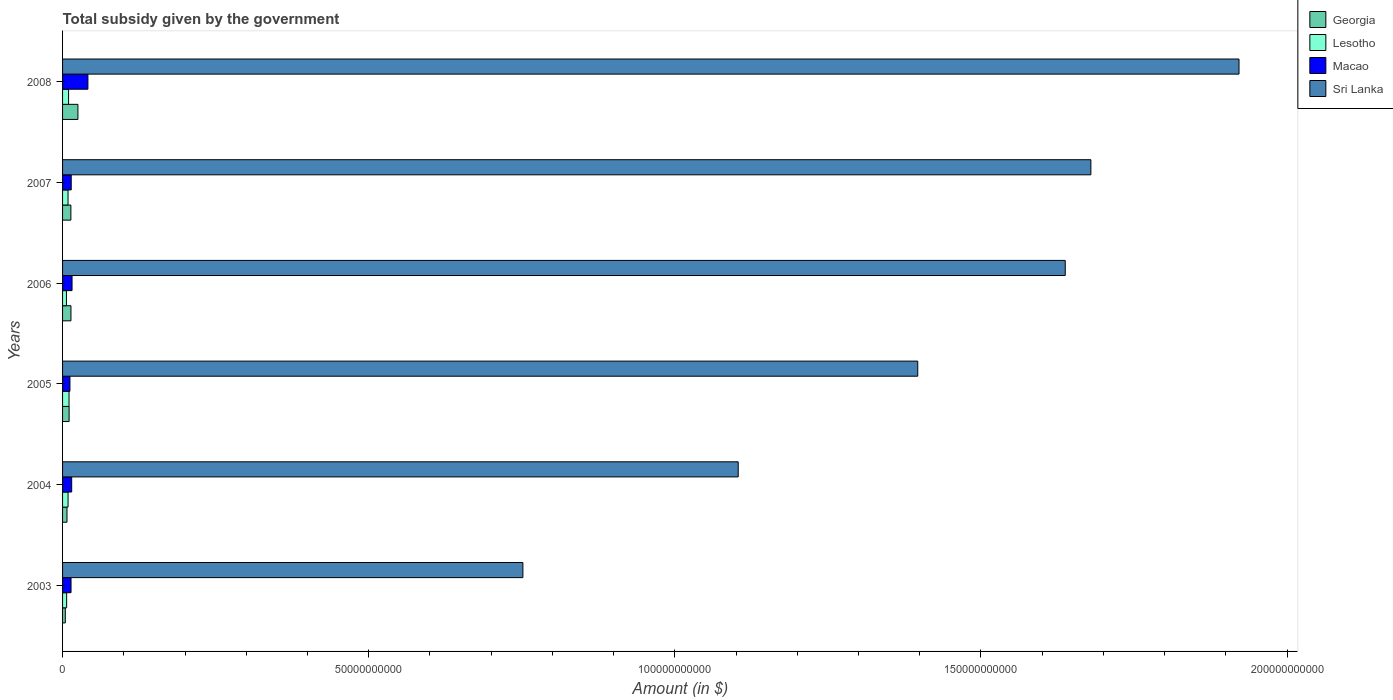How many different coloured bars are there?
Offer a very short reply. 4. Are the number of bars per tick equal to the number of legend labels?
Offer a very short reply. Yes. What is the label of the 3rd group of bars from the top?
Give a very brief answer. 2006. What is the total revenue collected by the government in Macao in 2004?
Your answer should be compact. 1.49e+09. Across all years, what is the maximum total revenue collected by the government in Georgia?
Keep it short and to the point. 2.51e+09. Across all years, what is the minimum total revenue collected by the government in Georgia?
Provide a short and direct response. 4.46e+08. What is the total total revenue collected by the government in Macao in the graph?
Offer a very short reply. 1.12e+1. What is the difference between the total revenue collected by the government in Macao in 2006 and that in 2008?
Offer a terse response. -2.59e+09. What is the difference between the total revenue collected by the government in Sri Lanka in 2006 and the total revenue collected by the government in Macao in 2008?
Give a very brief answer. 1.60e+11. What is the average total revenue collected by the government in Lesotho per year?
Make the answer very short. 8.54e+08. In the year 2006, what is the difference between the total revenue collected by the government in Macao and total revenue collected by the government in Georgia?
Keep it short and to the point. 1.79e+08. What is the ratio of the total revenue collected by the government in Macao in 2004 to that in 2007?
Your answer should be compact. 1.05. What is the difference between the highest and the second highest total revenue collected by the government in Sri Lanka?
Give a very brief answer. 2.42e+1. What is the difference between the highest and the lowest total revenue collected by the government in Georgia?
Your answer should be very brief. 2.06e+09. Is the sum of the total revenue collected by the government in Georgia in 2003 and 2008 greater than the maximum total revenue collected by the government in Lesotho across all years?
Provide a succinct answer. Yes. What does the 3rd bar from the top in 2006 represents?
Your response must be concise. Lesotho. What does the 2nd bar from the bottom in 2008 represents?
Offer a very short reply. Lesotho. Is it the case that in every year, the sum of the total revenue collected by the government in Lesotho and total revenue collected by the government in Sri Lanka is greater than the total revenue collected by the government in Georgia?
Offer a very short reply. Yes. How many bars are there?
Ensure brevity in your answer.  24. Are all the bars in the graph horizontal?
Offer a terse response. Yes. How many years are there in the graph?
Make the answer very short. 6. What is the difference between two consecutive major ticks on the X-axis?
Give a very brief answer. 5.00e+1. Are the values on the major ticks of X-axis written in scientific E-notation?
Make the answer very short. No. Does the graph contain any zero values?
Offer a very short reply. No. Where does the legend appear in the graph?
Your answer should be very brief. Top right. How many legend labels are there?
Your response must be concise. 4. How are the legend labels stacked?
Keep it short and to the point. Vertical. What is the title of the graph?
Ensure brevity in your answer.  Total subsidy given by the government. What is the label or title of the X-axis?
Make the answer very short. Amount (in $). What is the Amount (in $) of Georgia in 2003?
Offer a very short reply. 4.46e+08. What is the Amount (in $) in Lesotho in 2003?
Provide a succinct answer. 6.65e+08. What is the Amount (in $) in Macao in 2003?
Offer a very short reply. 1.38e+09. What is the Amount (in $) in Sri Lanka in 2003?
Offer a very short reply. 7.52e+1. What is the Amount (in $) of Georgia in 2004?
Your answer should be compact. 7.21e+08. What is the Amount (in $) of Lesotho in 2004?
Keep it short and to the point. 8.99e+08. What is the Amount (in $) in Macao in 2004?
Offer a terse response. 1.49e+09. What is the Amount (in $) in Sri Lanka in 2004?
Provide a short and direct response. 1.10e+11. What is the Amount (in $) of Georgia in 2005?
Keep it short and to the point. 1.07e+09. What is the Amount (in $) of Lesotho in 2005?
Provide a short and direct response. 1.06e+09. What is the Amount (in $) of Macao in 2005?
Offer a very short reply. 1.20e+09. What is the Amount (in $) of Sri Lanka in 2005?
Offer a terse response. 1.40e+11. What is the Amount (in $) of Georgia in 2006?
Provide a short and direct response. 1.37e+09. What is the Amount (in $) of Lesotho in 2006?
Provide a short and direct response. 6.32e+08. What is the Amount (in $) of Macao in 2006?
Your answer should be compact. 1.55e+09. What is the Amount (in $) of Sri Lanka in 2006?
Your answer should be very brief. 1.64e+11. What is the Amount (in $) of Georgia in 2007?
Your answer should be very brief. 1.36e+09. What is the Amount (in $) in Lesotho in 2007?
Your answer should be very brief. 8.93e+08. What is the Amount (in $) of Macao in 2007?
Your answer should be compact. 1.41e+09. What is the Amount (in $) in Sri Lanka in 2007?
Your answer should be very brief. 1.68e+11. What is the Amount (in $) in Georgia in 2008?
Offer a very short reply. 2.51e+09. What is the Amount (in $) of Lesotho in 2008?
Keep it short and to the point. 9.82e+08. What is the Amount (in $) in Macao in 2008?
Make the answer very short. 4.14e+09. What is the Amount (in $) of Sri Lanka in 2008?
Provide a succinct answer. 1.92e+11. Across all years, what is the maximum Amount (in $) of Georgia?
Your answer should be compact. 2.51e+09. Across all years, what is the maximum Amount (in $) of Lesotho?
Give a very brief answer. 1.06e+09. Across all years, what is the maximum Amount (in $) in Macao?
Offer a terse response. 4.14e+09. Across all years, what is the maximum Amount (in $) in Sri Lanka?
Ensure brevity in your answer.  1.92e+11. Across all years, what is the minimum Amount (in $) in Georgia?
Your response must be concise. 4.46e+08. Across all years, what is the minimum Amount (in $) of Lesotho?
Offer a very short reply. 6.32e+08. Across all years, what is the minimum Amount (in $) of Macao?
Give a very brief answer. 1.20e+09. Across all years, what is the minimum Amount (in $) of Sri Lanka?
Offer a terse response. 7.52e+1. What is the total Amount (in $) of Georgia in the graph?
Keep it short and to the point. 7.47e+09. What is the total Amount (in $) of Lesotho in the graph?
Keep it short and to the point. 5.13e+09. What is the total Amount (in $) of Macao in the graph?
Provide a succinct answer. 1.12e+1. What is the total Amount (in $) in Sri Lanka in the graph?
Provide a succinct answer. 8.49e+11. What is the difference between the Amount (in $) in Georgia in 2003 and that in 2004?
Your answer should be very brief. -2.75e+08. What is the difference between the Amount (in $) in Lesotho in 2003 and that in 2004?
Keep it short and to the point. -2.35e+08. What is the difference between the Amount (in $) of Macao in 2003 and that in 2004?
Give a very brief answer. -1.08e+08. What is the difference between the Amount (in $) in Sri Lanka in 2003 and that in 2004?
Offer a very short reply. -3.52e+1. What is the difference between the Amount (in $) in Georgia in 2003 and that in 2005?
Provide a succinct answer. -6.23e+08. What is the difference between the Amount (in $) of Lesotho in 2003 and that in 2005?
Provide a short and direct response. -3.91e+08. What is the difference between the Amount (in $) of Macao in 2003 and that in 2005?
Provide a short and direct response. 1.79e+08. What is the difference between the Amount (in $) in Sri Lanka in 2003 and that in 2005?
Your answer should be very brief. -6.45e+1. What is the difference between the Amount (in $) in Georgia in 2003 and that in 2006?
Offer a very short reply. -9.23e+08. What is the difference between the Amount (in $) of Lesotho in 2003 and that in 2006?
Keep it short and to the point. 3.29e+07. What is the difference between the Amount (in $) in Macao in 2003 and that in 2006?
Ensure brevity in your answer.  -1.67e+08. What is the difference between the Amount (in $) in Sri Lanka in 2003 and that in 2006?
Your answer should be very brief. -8.86e+1. What is the difference between the Amount (in $) in Georgia in 2003 and that in 2007?
Offer a very short reply. -9.11e+08. What is the difference between the Amount (in $) of Lesotho in 2003 and that in 2007?
Make the answer very short. -2.28e+08. What is the difference between the Amount (in $) in Macao in 2003 and that in 2007?
Your response must be concise. -3.09e+07. What is the difference between the Amount (in $) of Sri Lanka in 2003 and that in 2007?
Provide a short and direct response. -9.28e+1. What is the difference between the Amount (in $) in Georgia in 2003 and that in 2008?
Offer a terse response. -2.06e+09. What is the difference between the Amount (in $) in Lesotho in 2003 and that in 2008?
Your response must be concise. -3.17e+08. What is the difference between the Amount (in $) in Macao in 2003 and that in 2008?
Your answer should be very brief. -2.76e+09. What is the difference between the Amount (in $) in Sri Lanka in 2003 and that in 2008?
Offer a very short reply. -1.17e+11. What is the difference between the Amount (in $) of Georgia in 2004 and that in 2005?
Ensure brevity in your answer.  -3.48e+08. What is the difference between the Amount (in $) of Lesotho in 2004 and that in 2005?
Ensure brevity in your answer.  -1.57e+08. What is the difference between the Amount (in $) of Macao in 2004 and that in 2005?
Offer a very short reply. 2.87e+08. What is the difference between the Amount (in $) in Sri Lanka in 2004 and that in 2005?
Your response must be concise. -2.93e+1. What is the difference between the Amount (in $) of Georgia in 2004 and that in 2006?
Your answer should be very brief. -6.48e+08. What is the difference between the Amount (in $) in Lesotho in 2004 and that in 2006?
Provide a succinct answer. 2.67e+08. What is the difference between the Amount (in $) in Macao in 2004 and that in 2006?
Provide a succinct answer. -5.86e+07. What is the difference between the Amount (in $) of Sri Lanka in 2004 and that in 2006?
Ensure brevity in your answer.  -5.34e+1. What is the difference between the Amount (in $) in Georgia in 2004 and that in 2007?
Your answer should be very brief. -6.36e+08. What is the difference between the Amount (in $) of Lesotho in 2004 and that in 2007?
Keep it short and to the point. 6.40e+06. What is the difference between the Amount (in $) in Macao in 2004 and that in 2007?
Your response must be concise. 7.72e+07. What is the difference between the Amount (in $) in Sri Lanka in 2004 and that in 2007?
Your answer should be compact. -5.76e+1. What is the difference between the Amount (in $) in Georgia in 2004 and that in 2008?
Make the answer very short. -1.79e+09. What is the difference between the Amount (in $) of Lesotho in 2004 and that in 2008?
Give a very brief answer. -8.29e+07. What is the difference between the Amount (in $) of Macao in 2004 and that in 2008?
Your answer should be very brief. -2.65e+09. What is the difference between the Amount (in $) in Sri Lanka in 2004 and that in 2008?
Provide a succinct answer. -8.18e+1. What is the difference between the Amount (in $) in Georgia in 2005 and that in 2006?
Your response must be concise. -3.01e+08. What is the difference between the Amount (in $) in Lesotho in 2005 and that in 2006?
Keep it short and to the point. 4.24e+08. What is the difference between the Amount (in $) of Macao in 2005 and that in 2006?
Give a very brief answer. -3.46e+08. What is the difference between the Amount (in $) in Sri Lanka in 2005 and that in 2006?
Give a very brief answer. -2.41e+1. What is the difference between the Amount (in $) of Georgia in 2005 and that in 2007?
Give a very brief answer. -2.88e+08. What is the difference between the Amount (in $) in Lesotho in 2005 and that in 2007?
Provide a succinct answer. 1.63e+08. What is the difference between the Amount (in $) of Macao in 2005 and that in 2007?
Ensure brevity in your answer.  -2.10e+08. What is the difference between the Amount (in $) of Sri Lanka in 2005 and that in 2007?
Keep it short and to the point. -2.83e+1. What is the difference between the Amount (in $) in Georgia in 2005 and that in 2008?
Ensure brevity in your answer.  -1.44e+09. What is the difference between the Amount (in $) in Lesotho in 2005 and that in 2008?
Provide a succinct answer. 7.36e+07. What is the difference between the Amount (in $) in Macao in 2005 and that in 2008?
Keep it short and to the point. -2.93e+09. What is the difference between the Amount (in $) of Sri Lanka in 2005 and that in 2008?
Provide a short and direct response. -5.25e+1. What is the difference between the Amount (in $) in Georgia in 2006 and that in 2007?
Your answer should be very brief. 1.25e+07. What is the difference between the Amount (in $) of Lesotho in 2006 and that in 2007?
Offer a very short reply. -2.61e+08. What is the difference between the Amount (in $) in Macao in 2006 and that in 2007?
Provide a succinct answer. 1.36e+08. What is the difference between the Amount (in $) of Sri Lanka in 2006 and that in 2007?
Provide a succinct answer. -4.19e+09. What is the difference between the Amount (in $) of Georgia in 2006 and that in 2008?
Provide a succinct answer. -1.14e+09. What is the difference between the Amount (in $) in Lesotho in 2006 and that in 2008?
Keep it short and to the point. -3.50e+08. What is the difference between the Amount (in $) in Macao in 2006 and that in 2008?
Give a very brief answer. -2.59e+09. What is the difference between the Amount (in $) of Sri Lanka in 2006 and that in 2008?
Give a very brief answer. -2.84e+1. What is the difference between the Amount (in $) of Georgia in 2007 and that in 2008?
Your answer should be compact. -1.15e+09. What is the difference between the Amount (in $) of Lesotho in 2007 and that in 2008?
Your response must be concise. -8.93e+07. What is the difference between the Amount (in $) of Macao in 2007 and that in 2008?
Your answer should be compact. -2.72e+09. What is the difference between the Amount (in $) in Sri Lanka in 2007 and that in 2008?
Offer a terse response. -2.42e+1. What is the difference between the Amount (in $) of Georgia in 2003 and the Amount (in $) of Lesotho in 2004?
Give a very brief answer. -4.53e+08. What is the difference between the Amount (in $) in Georgia in 2003 and the Amount (in $) in Macao in 2004?
Your response must be concise. -1.04e+09. What is the difference between the Amount (in $) in Georgia in 2003 and the Amount (in $) in Sri Lanka in 2004?
Offer a terse response. -1.10e+11. What is the difference between the Amount (in $) in Lesotho in 2003 and the Amount (in $) in Macao in 2004?
Make the answer very short. -8.26e+08. What is the difference between the Amount (in $) in Lesotho in 2003 and the Amount (in $) in Sri Lanka in 2004?
Make the answer very short. -1.10e+11. What is the difference between the Amount (in $) in Macao in 2003 and the Amount (in $) in Sri Lanka in 2004?
Your response must be concise. -1.09e+11. What is the difference between the Amount (in $) of Georgia in 2003 and the Amount (in $) of Lesotho in 2005?
Provide a succinct answer. -6.09e+08. What is the difference between the Amount (in $) of Georgia in 2003 and the Amount (in $) of Macao in 2005?
Give a very brief answer. -7.57e+08. What is the difference between the Amount (in $) of Georgia in 2003 and the Amount (in $) of Sri Lanka in 2005?
Provide a short and direct response. -1.39e+11. What is the difference between the Amount (in $) in Lesotho in 2003 and the Amount (in $) in Macao in 2005?
Offer a terse response. -5.38e+08. What is the difference between the Amount (in $) in Lesotho in 2003 and the Amount (in $) in Sri Lanka in 2005?
Provide a short and direct response. -1.39e+11. What is the difference between the Amount (in $) in Macao in 2003 and the Amount (in $) in Sri Lanka in 2005?
Ensure brevity in your answer.  -1.38e+11. What is the difference between the Amount (in $) in Georgia in 2003 and the Amount (in $) in Lesotho in 2006?
Give a very brief answer. -1.86e+08. What is the difference between the Amount (in $) in Georgia in 2003 and the Amount (in $) in Macao in 2006?
Offer a terse response. -1.10e+09. What is the difference between the Amount (in $) in Georgia in 2003 and the Amount (in $) in Sri Lanka in 2006?
Provide a short and direct response. -1.63e+11. What is the difference between the Amount (in $) in Lesotho in 2003 and the Amount (in $) in Macao in 2006?
Offer a terse response. -8.84e+08. What is the difference between the Amount (in $) in Lesotho in 2003 and the Amount (in $) in Sri Lanka in 2006?
Your answer should be compact. -1.63e+11. What is the difference between the Amount (in $) in Macao in 2003 and the Amount (in $) in Sri Lanka in 2006?
Offer a terse response. -1.62e+11. What is the difference between the Amount (in $) of Georgia in 2003 and the Amount (in $) of Lesotho in 2007?
Offer a very short reply. -4.47e+08. What is the difference between the Amount (in $) of Georgia in 2003 and the Amount (in $) of Macao in 2007?
Your answer should be very brief. -9.67e+08. What is the difference between the Amount (in $) of Georgia in 2003 and the Amount (in $) of Sri Lanka in 2007?
Make the answer very short. -1.68e+11. What is the difference between the Amount (in $) in Lesotho in 2003 and the Amount (in $) in Macao in 2007?
Keep it short and to the point. -7.49e+08. What is the difference between the Amount (in $) of Lesotho in 2003 and the Amount (in $) of Sri Lanka in 2007?
Your answer should be compact. -1.67e+11. What is the difference between the Amount (in $) of Macao in 2003 and the Amount (in $) of Sri Lanka in 2007?
Ensure brevity in your answer.  -1.67e+11. What is the difference between the Amount (in $) in Georgia in 2003 and the Amount (in $) in Lesotho in 2008?
Your answer should be compact. -5.36e+08. What is the difference between the Amount (in $) in Georgia in 2003 and the Amount (in $) in Macao in 2008?
Your answer should be compact. -3.69e+09. What is the difference between the Amount (in $) in Georgia in 2003 and the Amount (in $) in Sri Lanka in 2008?
Provide a short and direct response. -1.92e+11. What is the difference between the Amount (in $) of Lesotho in 2003 and the Amount (in $) of Macao in 2008?
Provide a short and direct response. -3.47e+09. What is the difference between the Amount (in $) of Lesotho in 2003 and the Amount (in $) of Sri Lanka in 2008?
Provide a short and direct response. -1.91e+11. What is the difference between the Amount (in $) of Macao in 2003 and the Amount (in $) of Sri Lanka in 2008?
Your response must be concise. -1.91e+11. What is the difference between the Amount (in $) in Georgia in 2004 and the Amount (in $) in Lesotho in 2005?
Provide a succinct answer. -3.34e+08. What is the difference between the Amount (in $) of Georgia in 2004 and the Amount (in $) of Macao in 2005?
Your answer should be very brief. -4.82e+08. What is the difference between the Amount (in $) in Georgia in 2004 and the Amount (in $) in Sri Lanka in 2005?
Keep it short and to the point. -1.39e+11. What is the difference between the Amount (in $) of Lesotho in 2004 and the Amount (in $) of Macao in 2005?
Keep it short and to the point. -3.04e+08. What is the difference between the Amount (in $) in Lesotho in 2004 and the Amount (in $) in Sri Lanka in 2005?
Make the answer very short. -1.39e+11. What is the difference between the Amount (in $) in Macao in 2004 and the Amount (in $) in Sri Lanka in 2005?
Your response must be concise. -1.38e+11. What is the difference between the Amount (in $) in Georgia in 2004 and the Amount (in $) in Lesotho in 2006?
Your answer should be compact. 8.96e+07. What is the difference between the Amount (in $) of Georgia in 2004 and the Amount (in $) of Macao in 2006?
Ensure brevity in your answer.  -8.28e+08. What is the difference between the Amount (in $) of Georgia in 2004 and the Amount (in $) of Sri Lanka in 2006?
Offer a terse response. -1.63e+11. What is the difference between the Amount (in $) in Lesotho in 2004 and the Amount (in $) in Macao in 2006?
Offer a very short reply. -6.50e+08. What is the difference between the Amount (in $) of Lesotho in 2004 and the Amount (in $) of Sri Lanka in 2006?
Make the answer very short. -1.63e+11. What is the difference between the Amount (in $) of Macao in 2004 and the Amount (in $) of Sri Lanka in 2006?
Ensure brevity in your answer.  -1.62e+11. What is the difference between the Amount (in $) of Georgia in 2004 and the Amount (in $) of Lesotho in 2007?
Keep it short and to the point. -1.71e+08. What is the difference between the Amount (in $) of Georgia in 2004 and the Amount (in $) of Macao in 2007?
Offer a very short reply. -6.92e+08. What is the difference between the Amount (in $) of Georgia in 2004 and the Amount (in $) of Sri Lanka in 2007?
Offer a terse response. -1.67e+11. What is the difference between the Amount (in $) in Lesotho in 2004 and the Amount (in $) in Macao in 2007?
Make the answer very short. -5.14e+08. What is the difference between the Amount (in $) in Lesotho in 2004 and the Amount (in $) in Sri Lanka in 2007?
Your response must be concise. -1.67e+11. What is the difference between the Amount (in $) in Macao in 2004 and the Amount (in $) in Sri Lanka in 2007?
Your answer should be compact. -1.66e+11. What is the difference between the Amount (in $) of Georgia in 2004 and the Amount (in $) of Lesotho in 2008?
Offer a terse response. -2.61e+08. What is the difference between the Amount (in $) in Georgia in 2004 and the Amount (in $) in Macao in 2008?
Your answer should be compact. -3.42e+09. What is the difference between the Amount (in $) of Georgia in 2004 and the Amount (in $) of Sri Lanka in 2008?
Ensure brevity in your answer.  -1.91e+11. What is the difference between the Amount (in $) in Lesotho in 2004 and the Amount (in $) in Macao in 2008?
Provide a short and direct response. -3.24e+09. What is the difference between the Amount (in $) in Lesotho in 2004 and the Amount (in $) in Sri Lanka in 2008?
Keep it short and to the point. -1.91e+11. What is the difference between the Amount (in $) in Macao in 2004 and the Amount (in $) in Sri Lanka in 2008?
Make the answer very short. -1.91e+11. What is the difference between the Amount (in $) of Georgia in 2005 and the Amount (in $) of Lesotho in 2006?
Your answer should be compact. 4.37e+08. What is the difference between the Amount (in $) of Georgia in 2005 and the Amount (in $) of Macao in 2006?
Make the answer very short. -4.80e+08. What is the difference between the Amount (in $) in Georgia in 2005 and the Amount (in $) in Sri Lanka in 2006?
Your answer should be compact. -1.63e+11. What is the difference between the Amount (in $) in Lesotho in 2005 and the Amount (in $) in Macao in 2006?
Offer a terse response. -4.93e+08. What is the difference between the Amount (in $) of Lesotho in 2005 and the Amount (in $) of Sri Lanka in 2006?
Provide a succinct answer. -1.63e+11. What is the difference between the Amount (in $) in Macao in 2005 and the Amount (in $) in Sri Lanka in 2006?
Provide a succinct answer. -1.63e+11. What is the difference between the Amount (in $) in Georgia in 2005 and the Amount (in $) in Lesotho in 2007?
Your answer should be compact. 1.76e+08. What is the difference between the Amount (in $) in Georgia in 2005 and the Amount (in $) in Macao in 2007?
Your answer should be very brief. -3.44e+08. What is the difference between the Amount (in $) of Georgia in 2005 and the Amount (in $) of Sri Lanka in 2007?
Give a very brief answer. -1.67e+11. What is the difference between the Amount (in $) in Lesotho in 2005 and the Amount (in $) in Macao in 2007?
Ensure brevity in your answer.  -3.57e+08. What is the difference between the Amount (in $) in Lesotho in 2005 and the Amount (in $) in Sri Lanka in 2007?
Give a very brief answer. -1.67e+11. What is the difference between the Amount (in $) of Macao in 2005 and the Amount (in $) of Sri Lanka in 2007?
Provide a short and direct response. -1.67e+11. What is the difference between the Amount (in $) of Georgia in 2005 and the Amount (in $) of Lesotho in 2008?
Keep it short and to the point. 8.67e+07. What is the difference between the Amount (in $) in Georgia in 2005 and the Amount (in $) in Macao in 2008?
Your response must be concise. -3.07e+09. What is the difference between the Amount (in $) in Georgia in 2005 and the Amount (in $) in Sri Lanka in 2008?
Give a very brief answer. -1.91e+11. What is the difference between the Amount (in $) of Lesotho in 2005 and the Amount (in $) of Macao in 2008?
Offer a very short reply. -3.08e+09. What is the difference between the Amount (in $) in Lesotho in 2005 and the Amount (in $) in Sri Lanka in 2008?
Ensure brevity in your answer.  -1.91e+11. What is the difference between the Amount (in $) in Macao in 2005 and the Amount (in $) in Sri Lanka in 2008?
Make the answer very short. -1.91e+11. What is the difference between the Amount (in $) in Georgia in 2006 and the Amount (in $) in Lesotho in 2007?
Provide a short and direct response. 4.77e+08. What is the difference between the Amount (in $) of Georgia in 2006 and the Amount (in $) of Macao in 2007?
Give a very brief answer. -4.36e+07. What is the difference between the Amount (in $) in Georgia in 2006 and the Amount (in $) in Sri Lanka in 2007?
Your answer should be very brief. -1.67e+11. What is the difference between the Amount (in $) in Lesotho in 2006 and the Amount (in $) in Macao in 2007?
Give a very brief answer. -7.81e+08. What is the difference between the Amount (in $) in Lesotho in 2006 and the Amount (in $) in Sri Lanka in 2007?
Provide a succinct answer. -1.67e+11. What is the difference between the Amount (in $) of Macao in 2006 and the Amount (in $) of Sri Lanka in 2007?
Provide a short and direct response. -1.66e+11. What is the difference between the Amount (in $) in Georgia in 2006 and the Amount (in $) in Lesotho in 2008?
Provide a succinct answer. 3.87e+08. What is the difference between the Amount (in $) of Georgia in 2006 and the Amount (in $) of Macao in 2008?
Offer a very short reply. -2.77e+09. What is the difference between the Amount (in $) of Georgia in 2006 and the Amount (in $) of Sri Lanka in 2008?
Offer a terse response. -1.91e+11. What is the difference between the Amount (in $) of Lesotho in 2006 and the Amount (in $) of Macao in 2008?
Your answer should be compact. -3.51e+09. What is the difference between the Amount (in $) in Lesotho in 2006 and the Amount (in $) in Sri Lanka in 2008?
Keep it short and to the point. -1.92e+11. What is the difference between the Amount (in $) in Macao in 2006 and the Amount (in $) in Sri Lanka in 2008?
Provide a succinct answer. -1.91e+11. What is the difference between the Amount (in $) in Georgia in 2007 and the Amount (in $) in Lesotho in 2008?
Your answer should be very brief. 3.75e+08. What is the difference between the Amount (in $) of Georgia in 2007 and the Amount (in $) of Macao in 2008?
Ensure brevity in your answer.  -2.78e+09. What is the difference between the Amount (in $) in Georgia in 2007 and the Amount (in $) in Sri Lanka in 2008?
Provide a short and direct response. -1.91e+11. What is the difference between the Amount (in $) in Lesotho in 2007 and the Amount (in $) in Macao in 2008?
Give a very brief answer. -3.24e+09. What is the difference between the Amount (in $) of Lesotho in 2007 and the Amount (in $) of Sri Lanka in 2008?
Your answer should be compact. -1.91e+11. What is the difference between the Amount (in $) in Macao in 2007 and the Amount (in $) in Sri Lanka in 2008?
Provide a succinct answer. -1.91e+11. What is the average Amount (in $) in Georgia per year?
Provide a succinct answer. 1.25e+09. What is the average Amount (in $) in Lesotho per year?
Make the answer very short. 8.54e+08. What is the average Amount (in $) in Macao per year?
Your answer should be very brief. 1.86e+09. What is the average Amount (in $) of Sri Lanka per year?
Give a very brief answer. 1.42e+11. In the year 2003, what is the difference between the Amount (in $) of Georgia and Amount (in $) of Lesotho?
Your answer should be very brief. -2.18e+08. In the year 2003, what is the difference between the Amount (in $) of Georgia and Amount (in $) of Macao?
Provide a short and direct response. -9.36e+08. In the year 2003, what is the difference between the Amount (in $) in Georgia and Amount (in $) in Sri Lanka?
Offer a terse response. -7.47e+1. In the year 2003, what is the difference between the Amount (in $) of Lesotho and Amount (in $) of Macao?
Provide a succinct answer. -7.18e+08. In the year 2003, what is the difference between the Amount (in $) of Lesotho and Amount (in $) of Sri Lanka?
Give a very brief answer. -7.45e+1. In the year 2003, what is the difference between the Amount (in $) in Macao and Amount (in $) in Sri Lanka?
Ensure brevity in your answer.  -7.38e+1. In the year 2004, what is the difference between the Amount (in $) in Georgia and Amount (in $) in Lesotho?
Provide a short and direct response. -1.78e+08. In the year 2004, what is the difference between the Amount (in $) in Georgia and Amount (in $) in Macao?
Keep it short and to the point. -7.69e+08. In the year 2004, what is the difference between the Amount (in $) in Georgia and Amount (in $) in Sri Lanka?
Offer a terse response. -1.10e+11. In the year 2004, what is the difference between the Amount (in $) of Lesotho and Amount (in $) of Macao?
Offer a very short reply. -5.91e+08. In the year 2004, what is the difference between the Amount (in $) in Lesotho and Amount (in $) in Sri Lanka?
Your answer should be very brief. -1.09e+11. In the year 2004, what is the difference between the Amount (in $) in Macao and Amount (in $) in Sri Lanka?
Give a very brief answer. -1.09e+11. In the year 2005, what is the difference between the Amount (in $) in Georgia and Amount (in $) in Lesotho?
Your answer should be very brief. 1.32e+07. In the year 2005, what is the difference between the Amount (in $) of Georgia and Amount (in $) of Macao?
Ensure brevity in your answer.  -1.34e+08. In the year 2005, what is the difference between the Amount (in $) in Georgia and Amount (in $) in Sri Lanka?
Offer a very short reply. -1.39e+11. In the year 2005, what is the difference between the Amount (in $) of Lesotho and Amount (in $) of Macao?
Your answer should be compact. -1.47e+08. In the year 2005, what is the difference between the Amount (in $) in Lesotho and Amount (in $) in Sri Lanka?
Provide a succinct answer. -1.39e+11. In the year 2005, what is the difference between the Amount (in $) in Macao and Amount (in $) in Sri Lanka?
Ensure brevity in your answer.  -1.38e+11. In the year 2006, what is the difference between the Amount (in $) in Georgia and Amount (in $) in Lesotho?
Your answer should be very brief. 7.38e+08. In the year 2006, what is the difference between the Amount (in $) of Georgia and Amount (in $) of Macao?
Give a very brief answer. -1.79e+08. In the year 2006, what is the difference between the Amount (in $) of Georgia and Amount (in $) of Sri Lanka?
Your answer should be very brief. -1.62e+11. In the year 2006, what is the difference between the Amount (in $) of Lesotho and Amount (in $) of Macao?
Offer a terse response. -9.17e+08. In the year 2006, what is the difference between the Amount (in $) of Lesotho and Amount (in $) of Sri Lanka?
Make the answer very short. -1.63e+11. In the year 2006, what is the difference between the Amount (in $) of Macao and Amount (in $) of Sri Lanka?
Offer a very short reply. -1.62e+11. In the year 2007, what is the difference between the Amount (in $) in Georgia and Amount (in $) in Lesotho?
Ensure brevity in your answer.  4.64e+08. In the year 2007, what is the difference between the Amount (in $) of Georgia and Amount (in $) of Macao?
Provide a short and direct response. -5.61e+07. In the year 2007, what is the difference between the Amount (in $) of Georgia and Amount (in $) of Sri Lanka?
Your response must be concise. -1.67e+11. In the year 2007, what is the difference between the Amount (in $) in Lesotho and Amount (in $) in Macao?
Your answer should be very brief. -5.20e+08. In the year 2007, what is the difference between the Amount (in $) in Lesotho and Amount (in $) in Sri Lanka?
Your answer should be very brief. -1.67e+11. In the year 2007, what is the difference between the Amount (in $) in Macao and Amount (in $) in Sri Lanka?
Your answer should be very brief. -1.67e+11. In the year 2008, what is the difference between the Amount (in $) in Georgia and Amount (in $) in Lesotho?
Your answer should be very brief. 1.53e+09. In the year 2008, what is the difference between the Amount (in $) of Georgia and Amount (in $) of Macao?
Keep it short and to the point. -1.63e+09. In the year 2008, what is the difference between the Amount (in $) in Georgia and Amount (in $) in Sri Lanka?
Your answer should be compact. -1.90e+11. In the year 2008, what is the difference between the Amount (in $) in Lesotho and Amount (in $) in Macao?
Provide a short and direct response. -3.16e+09. In the year 2008, what is the difference between the Amount (in $) of Lesotho and Amount (in $) of Sri Lanka?
Make the answer very short. -1.91e+11. In the year 2008, what is the difference between the Amount (in $) in Macao and Amount (in $) in Sri Lanka?
Your answer should be compact. -1.88e+11. What is the ratio of the Amount (in $) in Georgia in 2003 to that in 2004?
Provide a short and direct response. 0.62. What is the ratio of the Amount (in $) of Lesotho in 2003 to that in 2004?
Offer a very short reply. 0.74. What is the ratio of the Amount (in $) in Macao in 2003 to that in 2004?
Your answer should be very brief. 0.93. What is the ratio of the Amount (in $) of Sri Lanka in 2003 to that in 2004?
Provide a short and direct response. 0.68. What is the ratio of the Amount (in $) in Georgia in 2003 to that in 2005?
Offer a terse response. 0.42. What is the ratio of the Amount (in $) in Lesotho in 2003 to that in 2005?
Offer a very short reply. 0.63. What is the ratio of the Amount (in $) in Macao in 2003 to that in 2005?
Offer a very short reply. 1.15. What is the ratio of the Amount (in $) in Sri Lanka in 2003 to that in 2005?
Give a very brief answer. 0.54. What is the ratio of the Amount (in $) in Georgia in 2003 to that in 2006?
Keep it short and to the point. 0.33. What is the ratio of the Amount (in $) of Lesotho in 2003 to that in 2006?
Provide a short and direct response. 1.05. What is the ratio of the Amount (in $) of Macao in 2003 to that in 2006?
Your answer should be compact. 0.89. What is the ratio of the Amount (in $) of Sri Lanka in 2003 to that in 2006?
Ensure brevity in your answer.  0.46. What is the ratio of the Amount (in $) of Georgia in 2003 to that in 2007?
Provide a succinct answer. 0.33. What is the ratio of the Amount (in $) in Lesotho in 2003 to that in 2007?
Provide a succinct answer. 0.74. What is the ratio of the Amount (in $) of Macao in 2003 to that in 2007?
Your response must be concise. 0.98. What is the ratio of the Amount (in $) in Sri Lanka in 2003 to that in 2007?
Provide a succinct answer. 0.45. What is the ratio of the Amount (in $) of Georgia in 2003 to that in 2008?
Your answer should be compact. 0.18. What is the ratio of the Amount (in $) of Lesotho in 2003 to that in 2008?
Offer a terse response. 0.68. What is the ratio of the Amount (in $) in Macao in 2003 to that in 2008?
Provide a short and direct response. 0.33. What is the ratio of the Amount (in $) of Sri Lanka in 2003 to that in 2008?
Give a very brief answer. 0.39. What is the ratio of the Amount (in $) in Georgia in 2004 to that in 2005?
Your response must be concise. 0.67. What is the ratio of the Amount (in $) of Lesotho in 2004 to that in 2005?
Ensure brevity in your answer.  0.85. What is the ratio of the Amount (in $) of Macao in 2004 to that in 2005?
Your answer should be compact. 1.24. What is the ratio of the Amount (in $) of Sri Lanka in 2004 to that in 2005?
Ensure brevity in your answer.  0.79. What is the ratio of the Amount (in $) of Georgia in 2004 to that in 2006?
Your answer should be compact. 0.53. What is the ratio of the Amount (in $) of Lesotho in 2004 to that in 2006?
Provide a short and direct response. 1.42. What is the ratio of the Amount (in $) of Macao in 2004 to that in 2006?
Your response must be concise. 0.96. What is the ratio of the Amount (in $) of Sri Lanka in 2004 to that in 2006?
Offer a very short reply. 0.67. What is the ratio of the Amount (in $) of Georgia in 2004 to that in 2007?
Make the answer very short. 0.53. What is the ratio of the Amount (in $) in Lesotho in 2004 to that in 2007?
Ensure brevity in your answer.  1.01. What is the ratio of the Amount (in $) of Macao in 2004 to that in 2007?
Your answer should be very brief. 1.05. What is the ratio of the Amount (in $) in Sri Lanka in 2004 to that in 2007?
Ensure brevity in your answer.  0.66. What is the ratio of the Amount (in $) of Georgia in 2004 to that in 2008?
Your answer should be very brief. 0.29. What is the ratio of the Amount (in $) in Lesotho in 2004 to that in 2008?
Provide a short and direct response. 0.92. What is the ratio of the Amount (in $) in Macao in 2004 to that in 2008?
Give a very brief answer. 0.36. What is the ratio of the Amount (in $) in Sri Lanka in 2004 to that in 2008?
Offer a very short reply. 0.57. What is the ratio of the Amount (in $) in Georgia in 2005 to that in 2006?
Ensure brevity in your answer.  0.78. What is the ratio of the Amount (in $) of Lesotho in 2005 to that in 2006?
Your response must be concise. 1.67. What is the ratio of the Amount (in $) in Macao in 2005 to that in 2006?
Offer a very short reply. 0.78. What is the ratio of the Amount (in $) in Sri Lanka in 2005 to that in 2006?
Your answer should be compact. 0.85. What is the ratio of the Amount (in $) in Georgia in 2005 to that in 2007?
Give a very brief answer. 0.79. What is the ratio of the Amount (in $) of Lesotho in 2005 to that in 2007?
Provide a succinct answer. 1.18. What is the ratio of the Amount (in $) of Macao in 2005 to that in 2007?
Offer a very short reply. 0.85. What is the ratio of the Amount (in $) in Sri Lanka in 2005 to that in 2007?
Your answer should be very brief. 0.83. What is the ratio of the Amount (in $) in Georgia in 2005 to that in 2008?
Keep it short and to the point. 0.43. What is the ratio of the Amount (in $) of Lesotho in 2005 to that in 2008?
Offer a terse response. 1.07. What is the ratio of the Amount (in $) of Macao in 2005 to that in 2008?
Ensure brevity in your answer.  0.29. What is the ratio of the Amount (in $) of Sri Lanka in 2005 to that in 2008?
Ensure brevity in your answer.  0.73. What is the ratio of the Amount (in $) of Georgia in 2006 to that in 2007?
Provide a succinct answer. 1.01. What is the ratio of the Amount (in $) in Lesotho in 2006 to that in 2007?
Your answer should be very brief. 0.71. What is the ratio of the Amount (in $) of Macao in 2006 to that in 2007?
Keep it short and to the point. 1.1. What is the ratio of the Amount (in $) of Sri Lanka in 2006 to that in 2007?
Provide a short and direct response. 0.98. What is the ratio of the Amount (in $) of Georgia in 2006 to that in 2008?
Provide a succinct answer. 0.55. What is the ratio of the Amount (in $) in Lesotho in 2006 to that in 2008?
Offer a very short reply. 0.64. What is the ratio of the Amount (in $) of Macao in 2006 to that in 2008?
Offer a terse response. 0.37. What is the ratio of the Amount (in $) of Sri Lanka in 2006 to that in 2008?
Provide a succinct answer. 0.85. What is the ratio of the Amount (in $) of Georgia in 2007 to that in 2008?
Ensure brevity in your answer.  0.54. What is the ratio of the Amount (in $) of Lesotho in 2007 to that in 2008?
Offer a very short reply. 0.91. What is the ratio of the Amount (in $) in Macao in 2007 to that in 2008?
Keep it short and to the point. 0.34. What is the ratio of the Amount (in $) in Sri Lanka in 2007 to that in 2008?
Your answer should be compact. 0.87. What is the difference between the highest and the second highest Amount (in $) of Georgia?
Your answer should be compact. 1.14e+09. What is the difference between the highest and the second highest Amount (in $) in Lesotho?
Make the answer very short. 7.36e+07. What is the difference between the highest and the second highest Amount (in $) of Macao?
Your answer should be compact. 2.59e+09. What is the difference between the highest and the second highest Amount (in $) of Sri Lanka?
Provide a short and direct response. 2.42e+1. What is the difference between the highest and the lowest Amount (in $) of Georgia?
Ensure brevity in your answer.  2.06e+09. What is the difference between the highest and the lowest Amount (in $) in Lesotho?
Provide a short and direct response. 4.24e+08. What is the difference between the highest and the lowest Amount (in $) in Macao?
Ensure brevity in your answer.  2.93e+09. What is the difference between the highest and the lowest Amount (in $) in Sri Lanka?
Offer a terse response. 1.17e+11. 